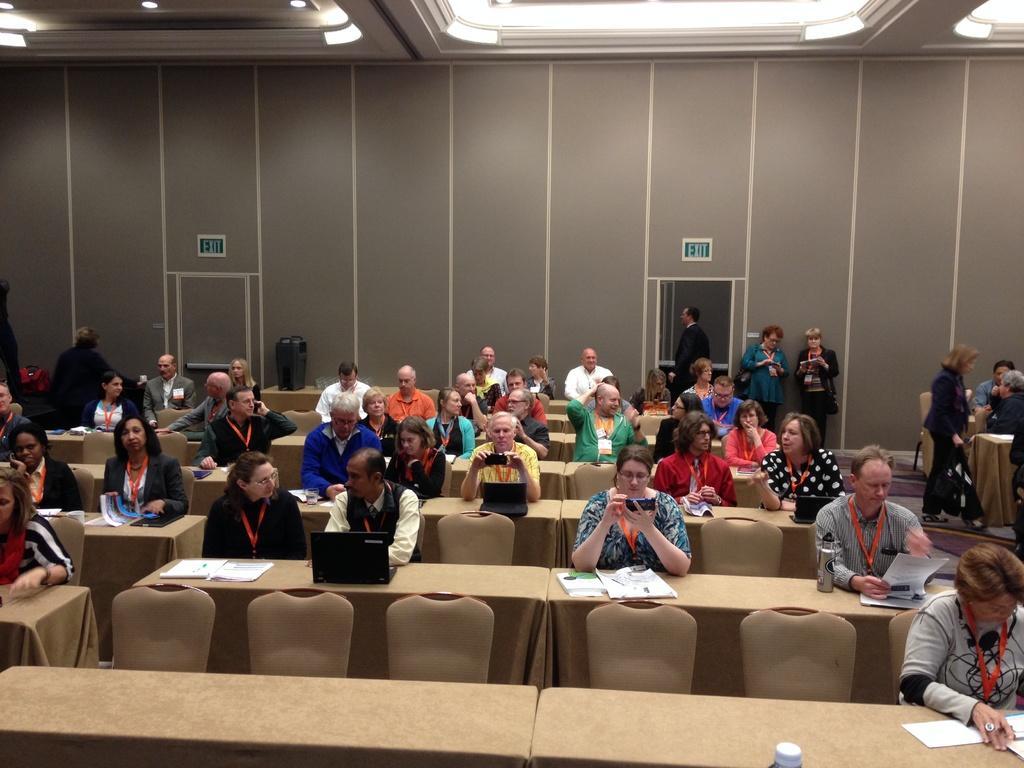In one or two sentences, can you explain what this image depicts? In this image I can see number of people were few are standing and rest all are sitting. I can see a laptop in front of a man. In the background I can see a wall with exit written on it. 